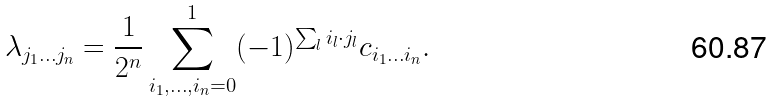<formula> <loc_0><loc_0><loc_500><loc_500>\lambda _ { j _ { 1 } \dots j _ { n } } = \frac { 1 } { 2 ^ { n } } \sum _ { i _ { 1 } , \dots , i _ { n } = 0 } ^ { 1 } ( - 1 ) ^ { \sum _ { l } i _ { l } \cdot j _ { l } } c _ { i _ { 1 } \dots i _ { n } } .</formula> 